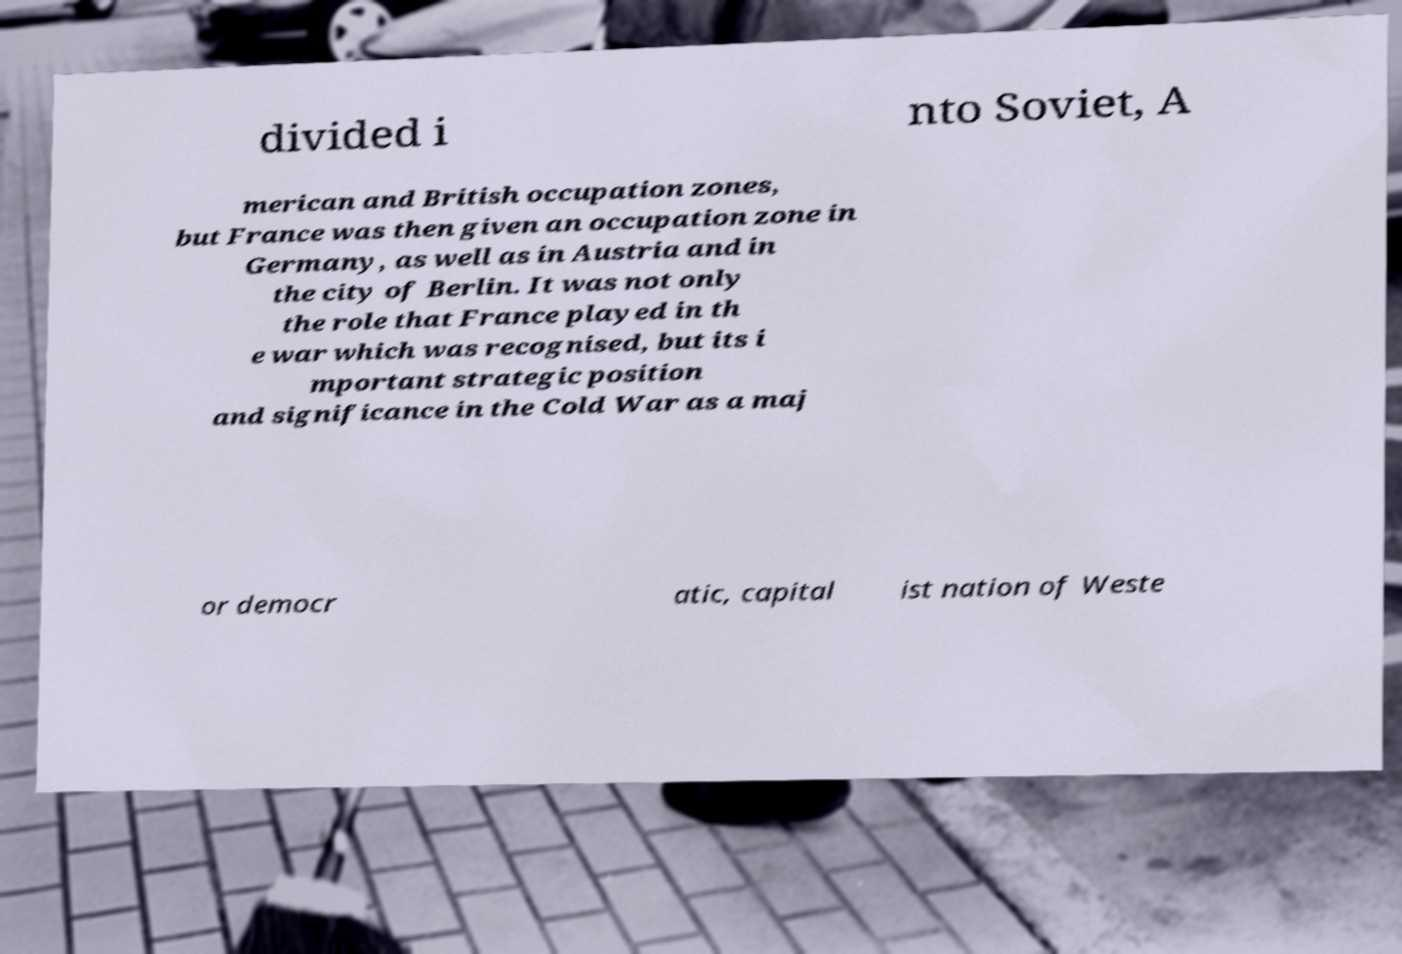Can you read and provide the text displayed in the image?This photo seems to have some interesting text. Can you extract and type it out for me? divided i nto Soviet, A merican and British occupation zones, but France was then given an occupation zone in Germany, as well as in Austria and in the city of Berlin. It was not only the role that France played in th e war which was recognised, but its i mportant strategic position and significance in the Cold War as a maj or democr atic, capital ist nation of Weste 